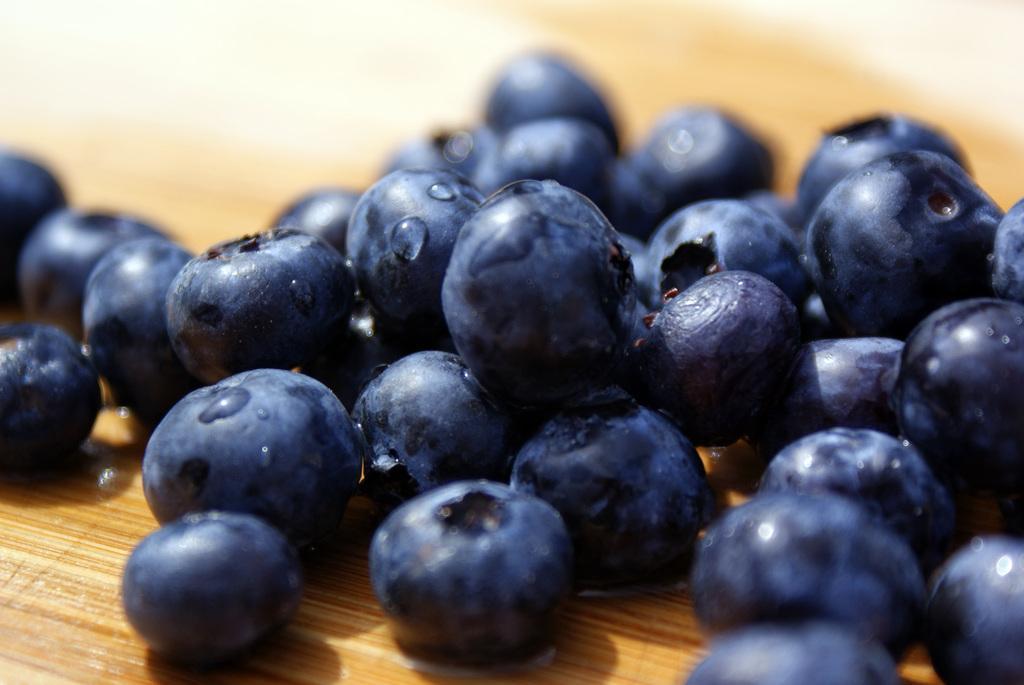Could you give a brief overview of what you see in this image? In this image we can see berries placed on the wooden surface. 